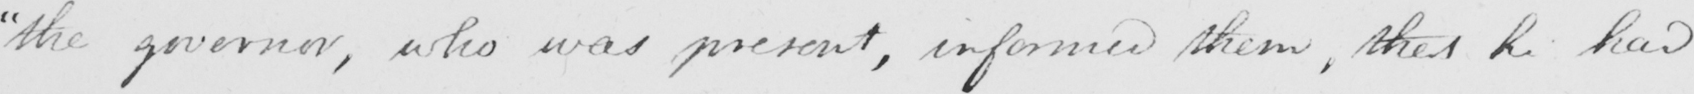Please provide the text content of this handwritten line. " the governor , who was present , informed them , that he had 